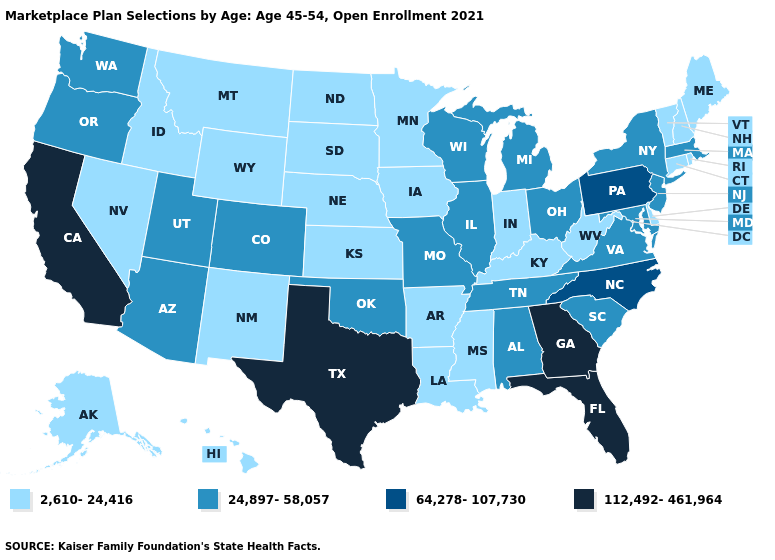What is the lowest value in the South?
Answer briefly. 2,610-24,416. Does Georgia have the lowest value in the USA?
Write a very short answer. No. Is the legend a continuous bar?
Give a very brief answer. No. What is the value of Alabama?
Be succinct. 24,897-58,057. Which states have the lowest value in the USA?
Quick response, please. Alaska, Arkansas, Connecticut, Delaware, Hawaii, Idaho, Indiana, Iowa, Kansas, Kentucky, Louisiana, Maine, Minnesota, Mississippi, Montana, Nebraska, Nevada, New Hampshire, New Mexico, North Dakota, Rhode Island, South Dakota, Vermont, West Virginia, Wyoming. Name the states that have a value in the range 64,278-107,730?
Quick response, please. North Carolina, Pennsylvania. Which states have the highest value in the USA?
Quick response, please. California, Florida, Georgia, Texas. Which states have the highest value in the USA?
Quick response, please. California, Florida, Georgia, Texas. Name the states that have a value in the range 2,610-24,416?
Be succinct. Alaska, Arkansas, Connecticut, Delaware, Hawaii, Idaho, Indiana, Iowa, Kansas, Kentucky, Louisiana, Maine, Minnesota, Mississippi, Montana, Nebraska, Nevada, New Hampshire, New Mexico, North Dakota, Rhode Island, South Dakota, Vermont, West Virginia, Wyoming. Name the states that have a value in the range 64,278-107,730?
Keep it brief. North Carolina, Pennsylvania. Among the states that border New Mexico , does Texas have the highest value?
Quick response, please. Yes. What is the value of Mississippi?
Short answer required. 2,610-24,416. What is the highest value in the South ?
Answer briefly. 112,492-461,964. Which states hav the highest value in the West?
Be succinct. California. Name the states that have a value in the range 2,610-24,416?
Quick response, please. Alaska, Arkansas, Connecticut, Delaware, Hawaii, Idaho, Indiana, Iowa, Kansas, Kentucky, Louisiana, Maine, Minnesota, Mississippi, Montana, Nebraska, Nevada, New Hampshire, New Mexico, North Dakota, Rhode Island, South Dakota, Vermont, West Virginia, Wyoming. 